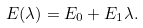Convert formula to latex. <formula><loc_0><loc_0><loc_500><loc_500>E ( \lambda ) = E _ { 0 } + E _ { 1 } \lambda .</formula> 